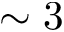Convert formula to latex. <formula><loc_0><loc_0><loc_500><loc_500>\sim 3</formula> 